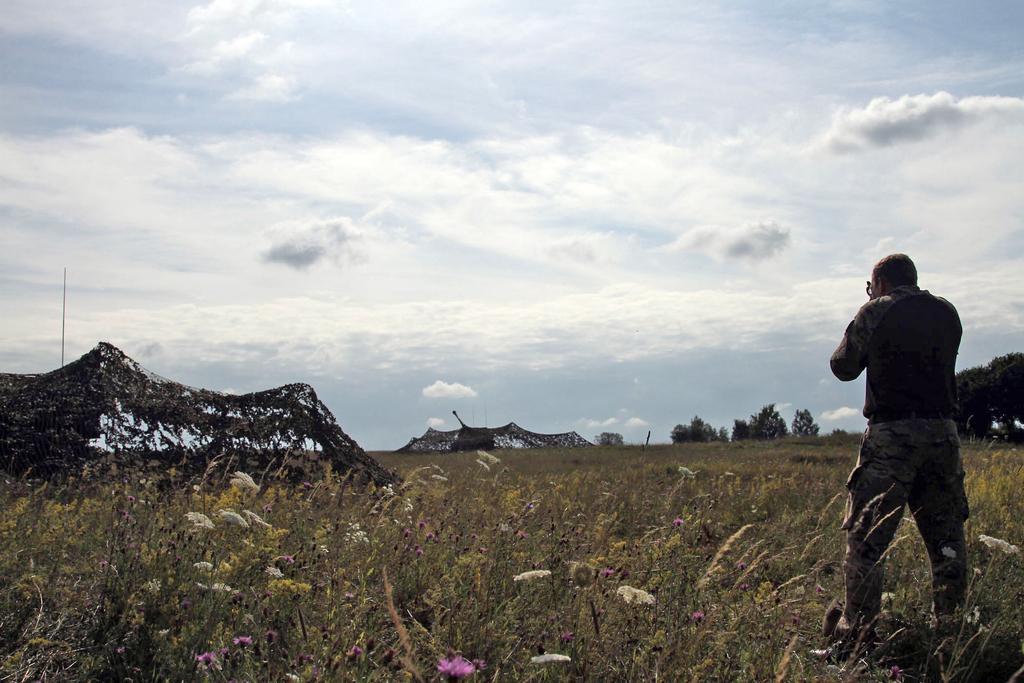In one or two sentences, can you explain what this image depicts? In this image there is a man standing on the ground. On the left side there is a net. At the bottom there are flower plants. At the top there is the sky. In the background there is another net, beside it there are trees. 